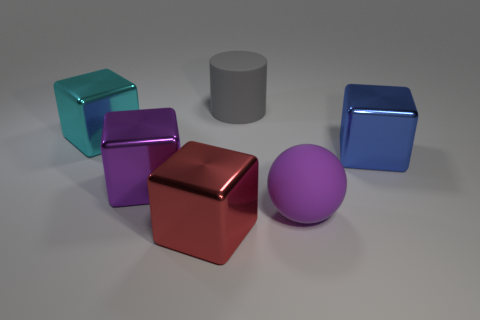Subtract all large blue metal blocks. How many blocks are left? 3 Subtract all purple cubes. How many cubes are left? 3 Add 2 small cyan metal spheres. How many objects exist? 8 Subtract all green blocks. Subtract all blue cylinders. How many blocks are left? 4 Add 2 large cyan objects. How many large cyan objects exist? 3 Subtract 0 blue spheres. How many objects are left? 6 Subtract all cubes. How many objects are left? 2 Subtract all blue shiny balls. Subtract all big metal blocks. How many objects are left? 2 Add 2 blue metal cubes. How many blue metal cubes are left? 3 